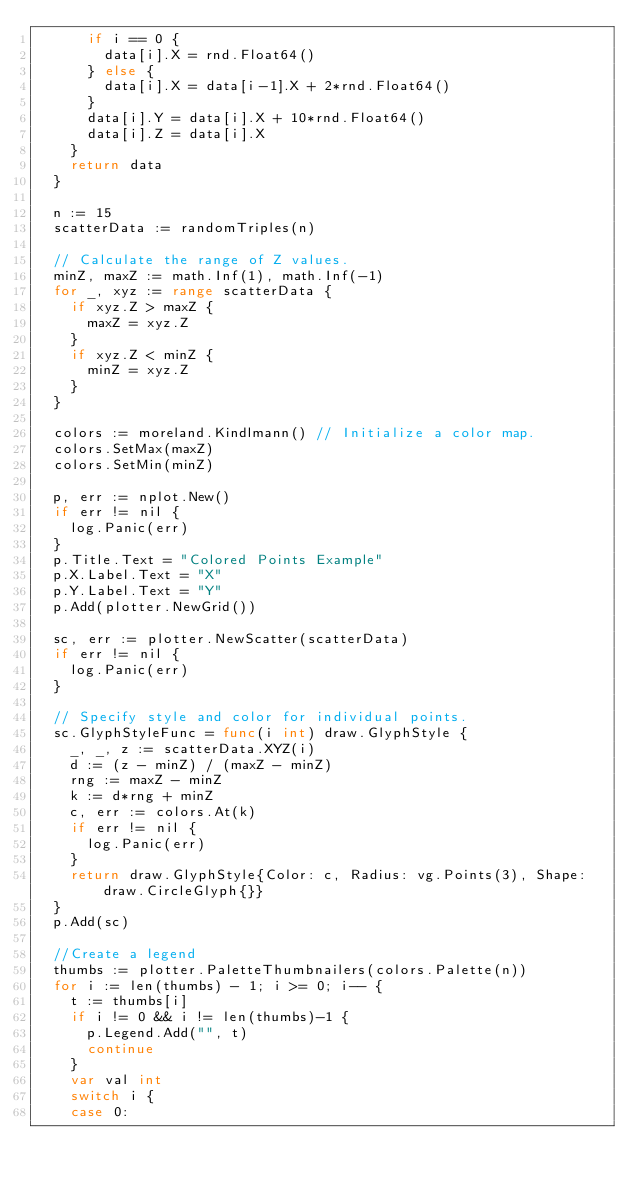<code> <loc_0><loc_0><loc_500><loc_500><_Go_>			if i == 0 {
				data[i].X = rnd.Float64()
			} else {
				data[i].X = data[i-1].X + 2*rnd.Float64()
			}
			data[i].Y = data[i].X + 10*rnd.Float64()
			data[i].Z = data[i].X
		}
		return data
	}

	n := 15
	scatterData := randomTriples(n)

	// Calculate the range of Z values.
	minZ, maxZ := math.Inf(1), math.Inf(-1)
	for _, xyz := range scatterData {
		if xyz.Z > maxZ {
			maxZ = xyz.Z
		}
		if xyz.Z < minZ {
			minZ = xyz.Z
		}
	}

	colors := moreland.Kindlmann() // Initialize a color map.
	colors.SetMax(maxZ)
	colors.SetMin(minZ)

	p, err := nplot.New()
	if err != nil {
		log.Panic(err)
	}
	p.Title.Text = "Colored Points Example"
	p.X.Label.Text = "X"
	p.Y.Label.Text = "Y"
	p.Add(plotter.NewGrid())

	sc, err := plotter.NewScatter(scatterData)
	if err != nil {
		log.Panic(err)
	}

	// Specify style and color for individual points.
	sc.GlyphStyleFunc = func(i int) draw.GlyphStyle {
		_, _, z := scatterData.XYZ(i)
		d := (z - minZ) / (maxZ - minZ)
		rng := maxZ - minZ
		k := d*rng + minZ
		c, err := colors.At(k)
		if err != nil {
			log.Panic(err)
		}
		return draw.GlyphStyle{Color: c, Radius: vg.Points(3), Shape: draw.CircleGlyph{}}
	}
	p.Add(sc)

	//Create a legend
	thumbs := plotter.PaletteThumbnailers(colors.Palette(n))
	for i := len(thumbs) - 1; i >= 0; i-- {
		t := thumbs[i]
		if i != 0 && i != len(thumbs)-1 {
			p.Legend.Add("", t)
			continue
		}
		var val int
		switch i {
		case 0:</code> 